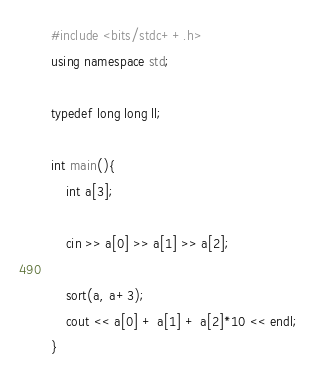Convert code to text. <code><loc_0><loc_0><loc_500><loc_500><_C++_>#include <bits/stdc++.h>
using namespace std;

typedef long long ll;

int main(){
    int a[3];

    cin >> a[0] >> a[1] >> a[2];

    sort(a, a+3); 
    cout << a[0] + a[1] + a[2]*10 << endl;
}</code> 